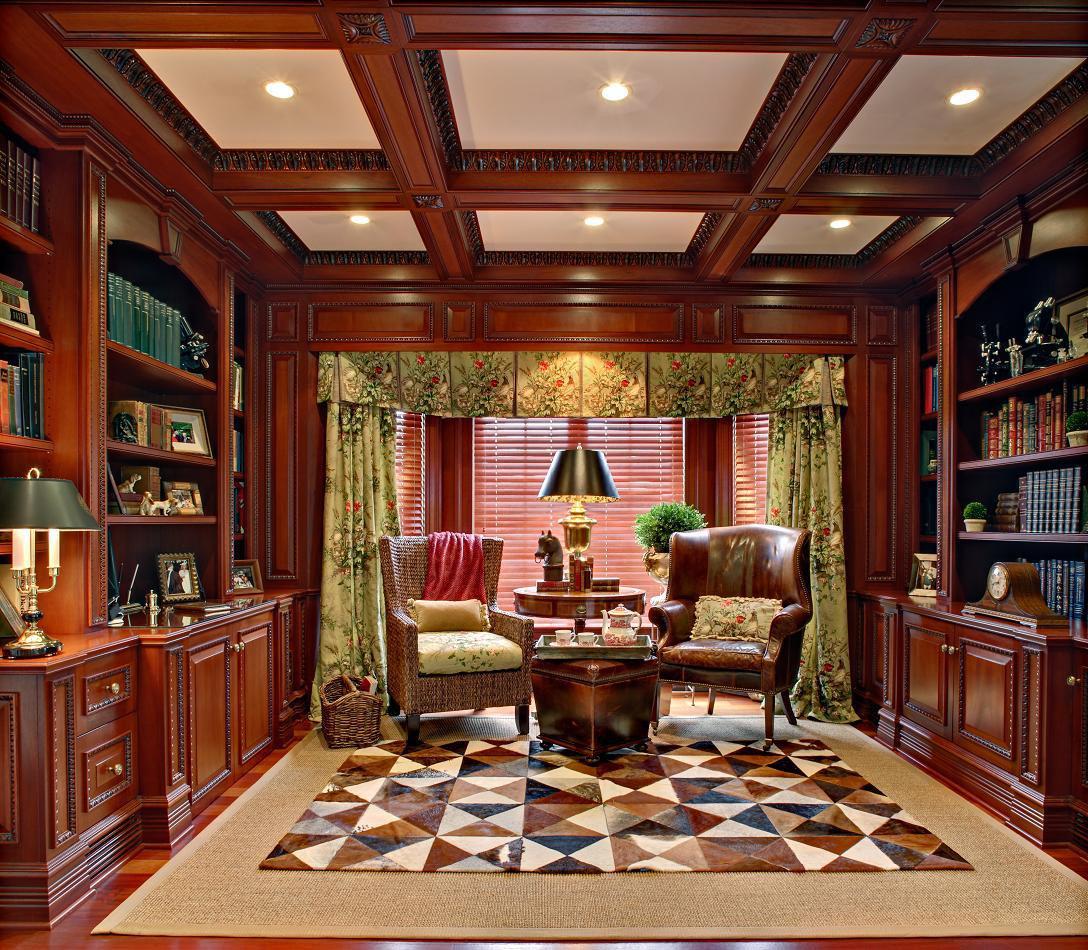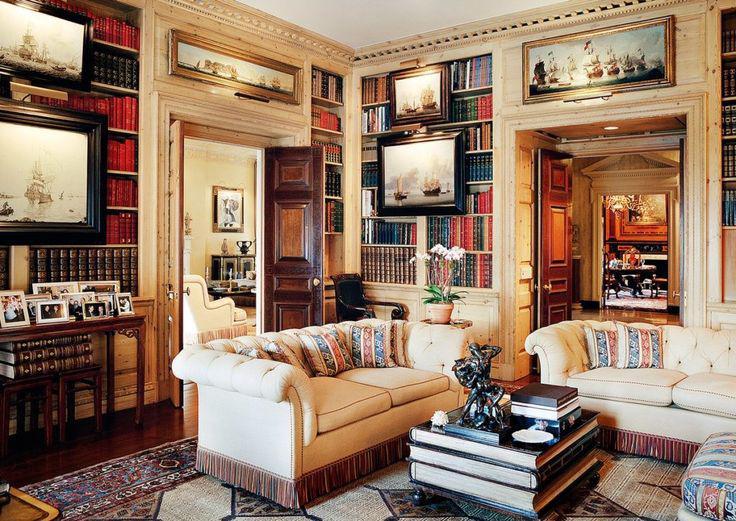The first image is the image on the left, the second image is the image on the right. Assess this claim about the two images: "In at least one of the images there is a lamp suspended on a visible chain from the ceiling.". Correct or not? Answer yes or no. No. The first image is the image on the left, the second image is the image on the right. Analyze the images presented: Is the assertion "There is a fireplace in at least one of the images." valid? Answer yes or no. No. 